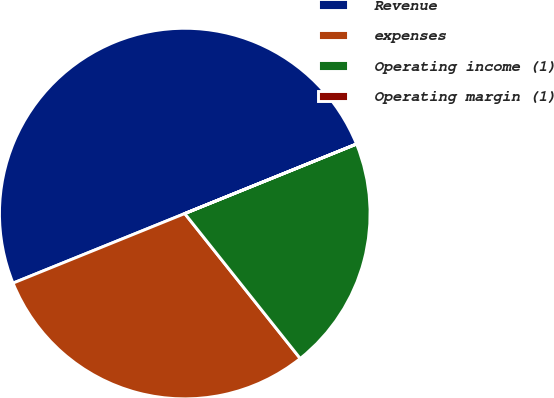Convert chart. <chart><loc_0><loc_0><loc_500><loc_500><pie_chart><fcel>Revenue<fcel>expenses<fcel>Operating income (1)<fcel>Operating margin (1)<nl><fcel>49.99%<fcel>29.58%<fcel>20.41%<fcel>0.01%<nl></chart> 